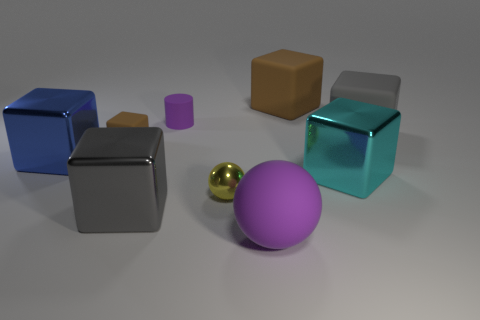What number of yellow things are the same shape as the tiny purple object?
Your response must be concise. 0. Is the color of the rubber cube left of the big purple rubber thing the same as the cube that is behind the gray rubber cube?
Give a very brief answer. Yes. What is the material of the blue thing that is the same size as the cyan object?
Your answer should be compact. Metal. Are there any cyan objects that have the same size as the purple matte ball?
Give a very brief answer. Yes. Is the number of rubber cubes on the left side of the metal sphere less than the number of big things?
Offer a terse response. Yes. Is the number of big gray cubes behind the big purple rubber ball less than the number of small matte cubes that are to the right of the big gray rubber cube?
Your response must be concise. No. What number of spheres are blue things or yellow objects?
Your answer should be compact. 1. Does the big gray block that is right of the big cyan object have the same material as the gray cube that is in front of the large cyan metal cube?
Ensure brevity in your answer.  No. What is the shape of the brown rubber thing that is the same size as the yellow metallic thing?
Make the answer very short. Cube. What number of other objects are the same color as the tiny metallic thing?
Make the answer very short. 0. 